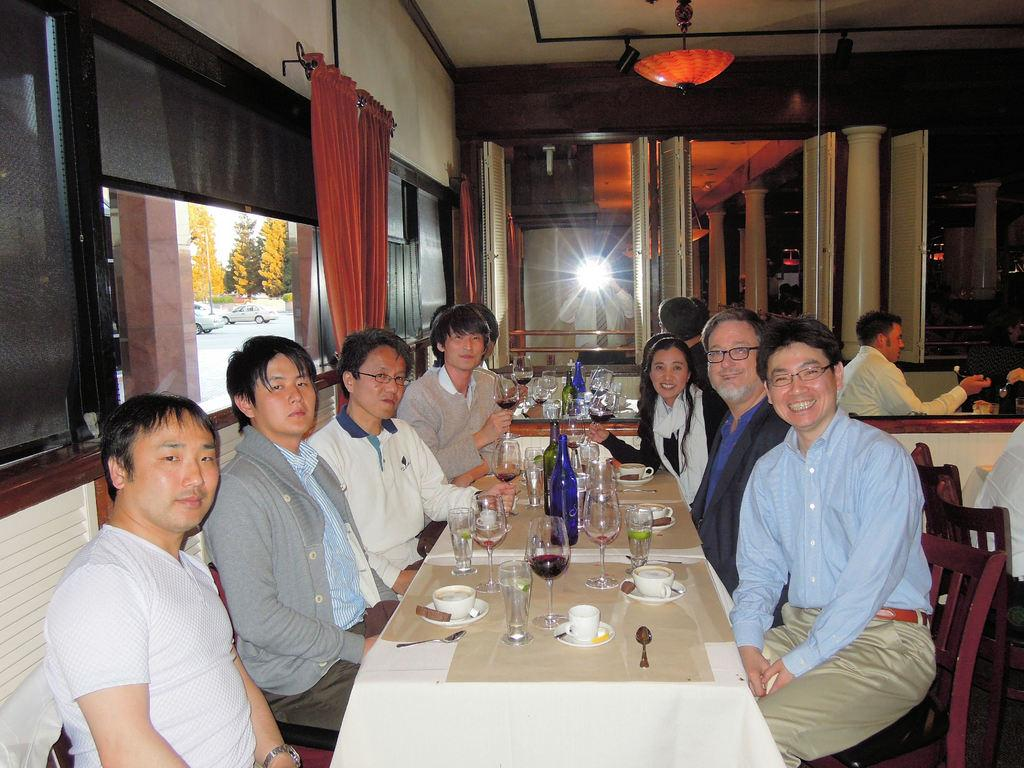What is happening in the image? There are people sitting around a table in the image. What objects can be seen on the table? The table has a glass, a cup, a spoon, and a bottle. What is the size and location of the window in the image? There is a big window behind the person in the image. What type of cheese is being served on the table in the image? There is no cheese present in the image. Is there a crown on the table in the image? There is no crown present in the image. 